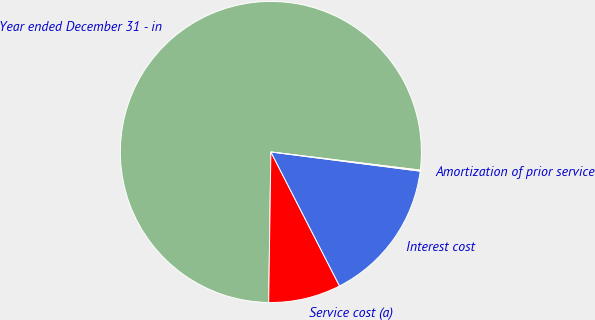<chart> <loc_0><loc_0><loc_500><loc_500><pie_chart><fcel>Year ended December 31 - in<fcel>Service cost (a)<fcel>Interest cost<fcel>Amortization of prior service<nl><fcel>76.69%<fcel>7.77%<fcel>15.43%<fcel>0.11%<nl></chart> 